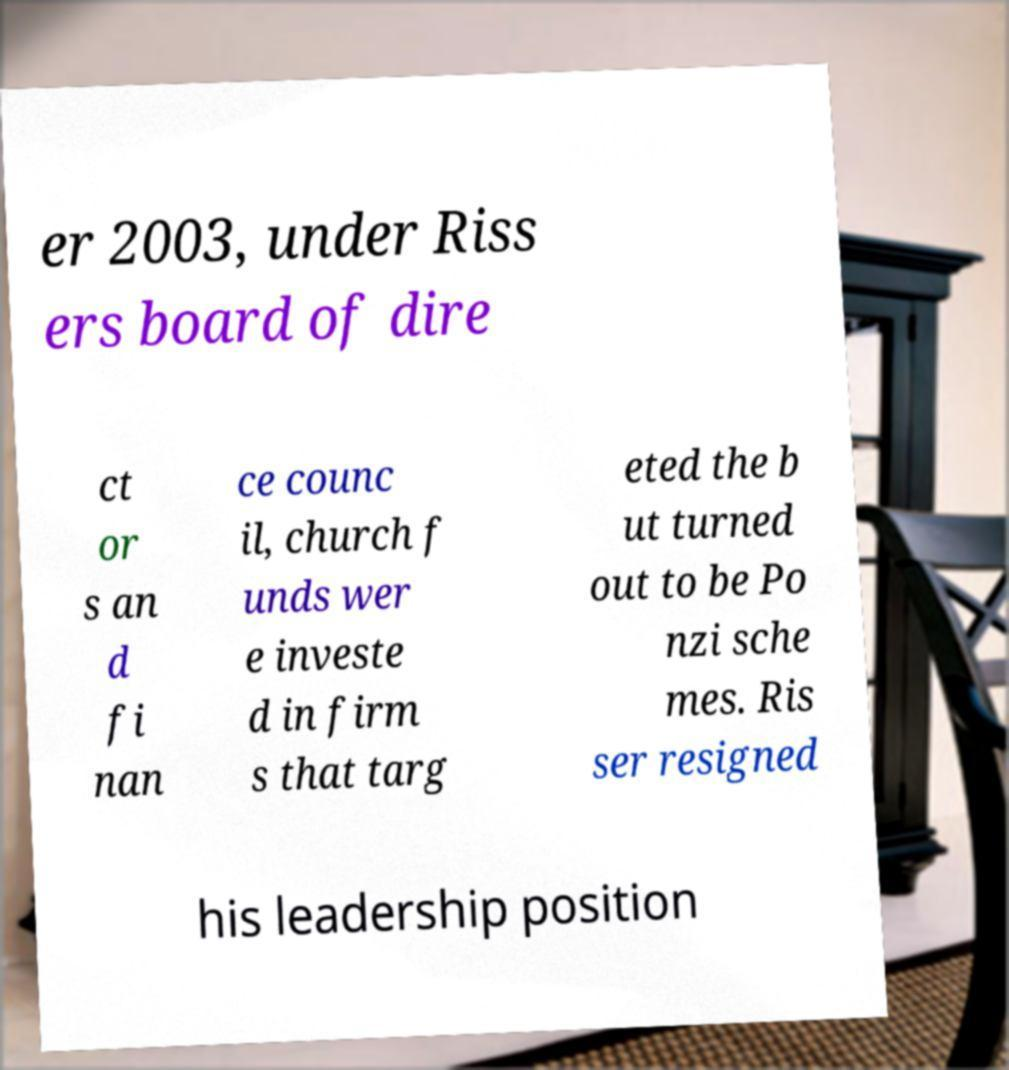What messages or text are displayed in this image? I need them in a readable, typed format. er 2003, under Riss ers board of dire ct or s an d fi nan ce counc il, church f unds wer e investe d in firm s that targ eted the b ut turned out to be Po nzi sche mes. Ris ser resigned his leadership position 